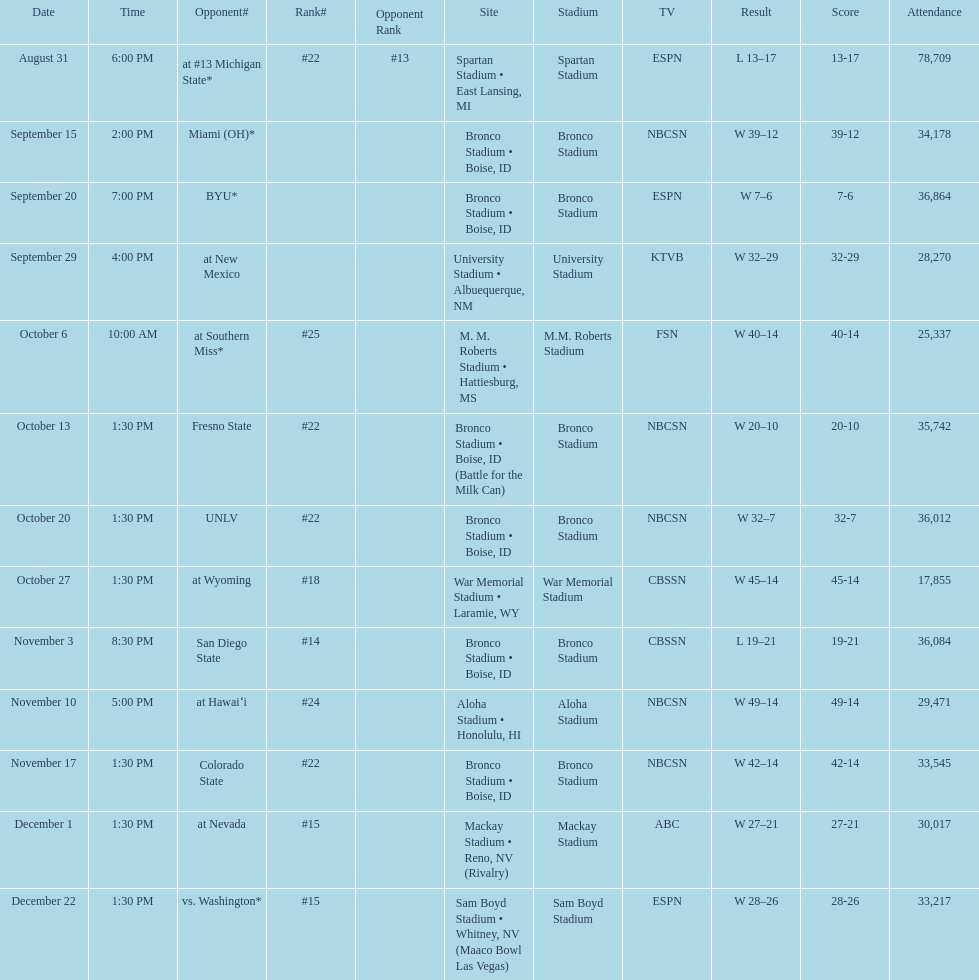Opponent broncos faced next after unlv Wyoming. 